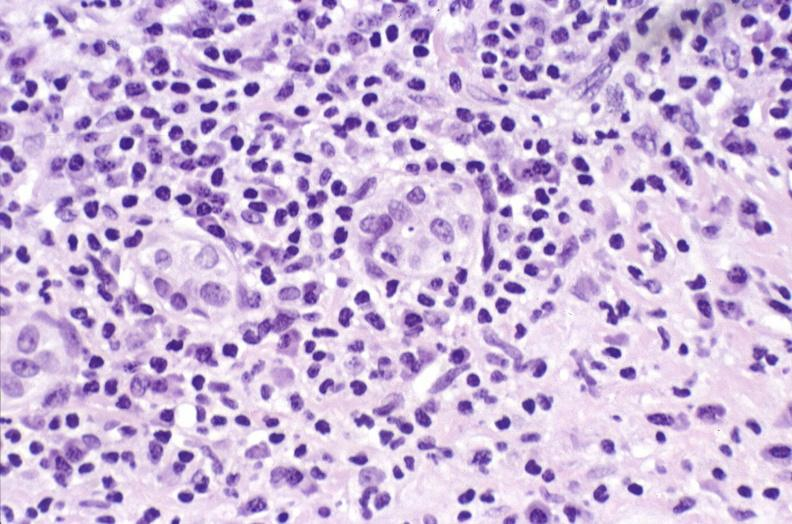s hepatobiliary present?
Answer the question using a single word or phrase. Yes 